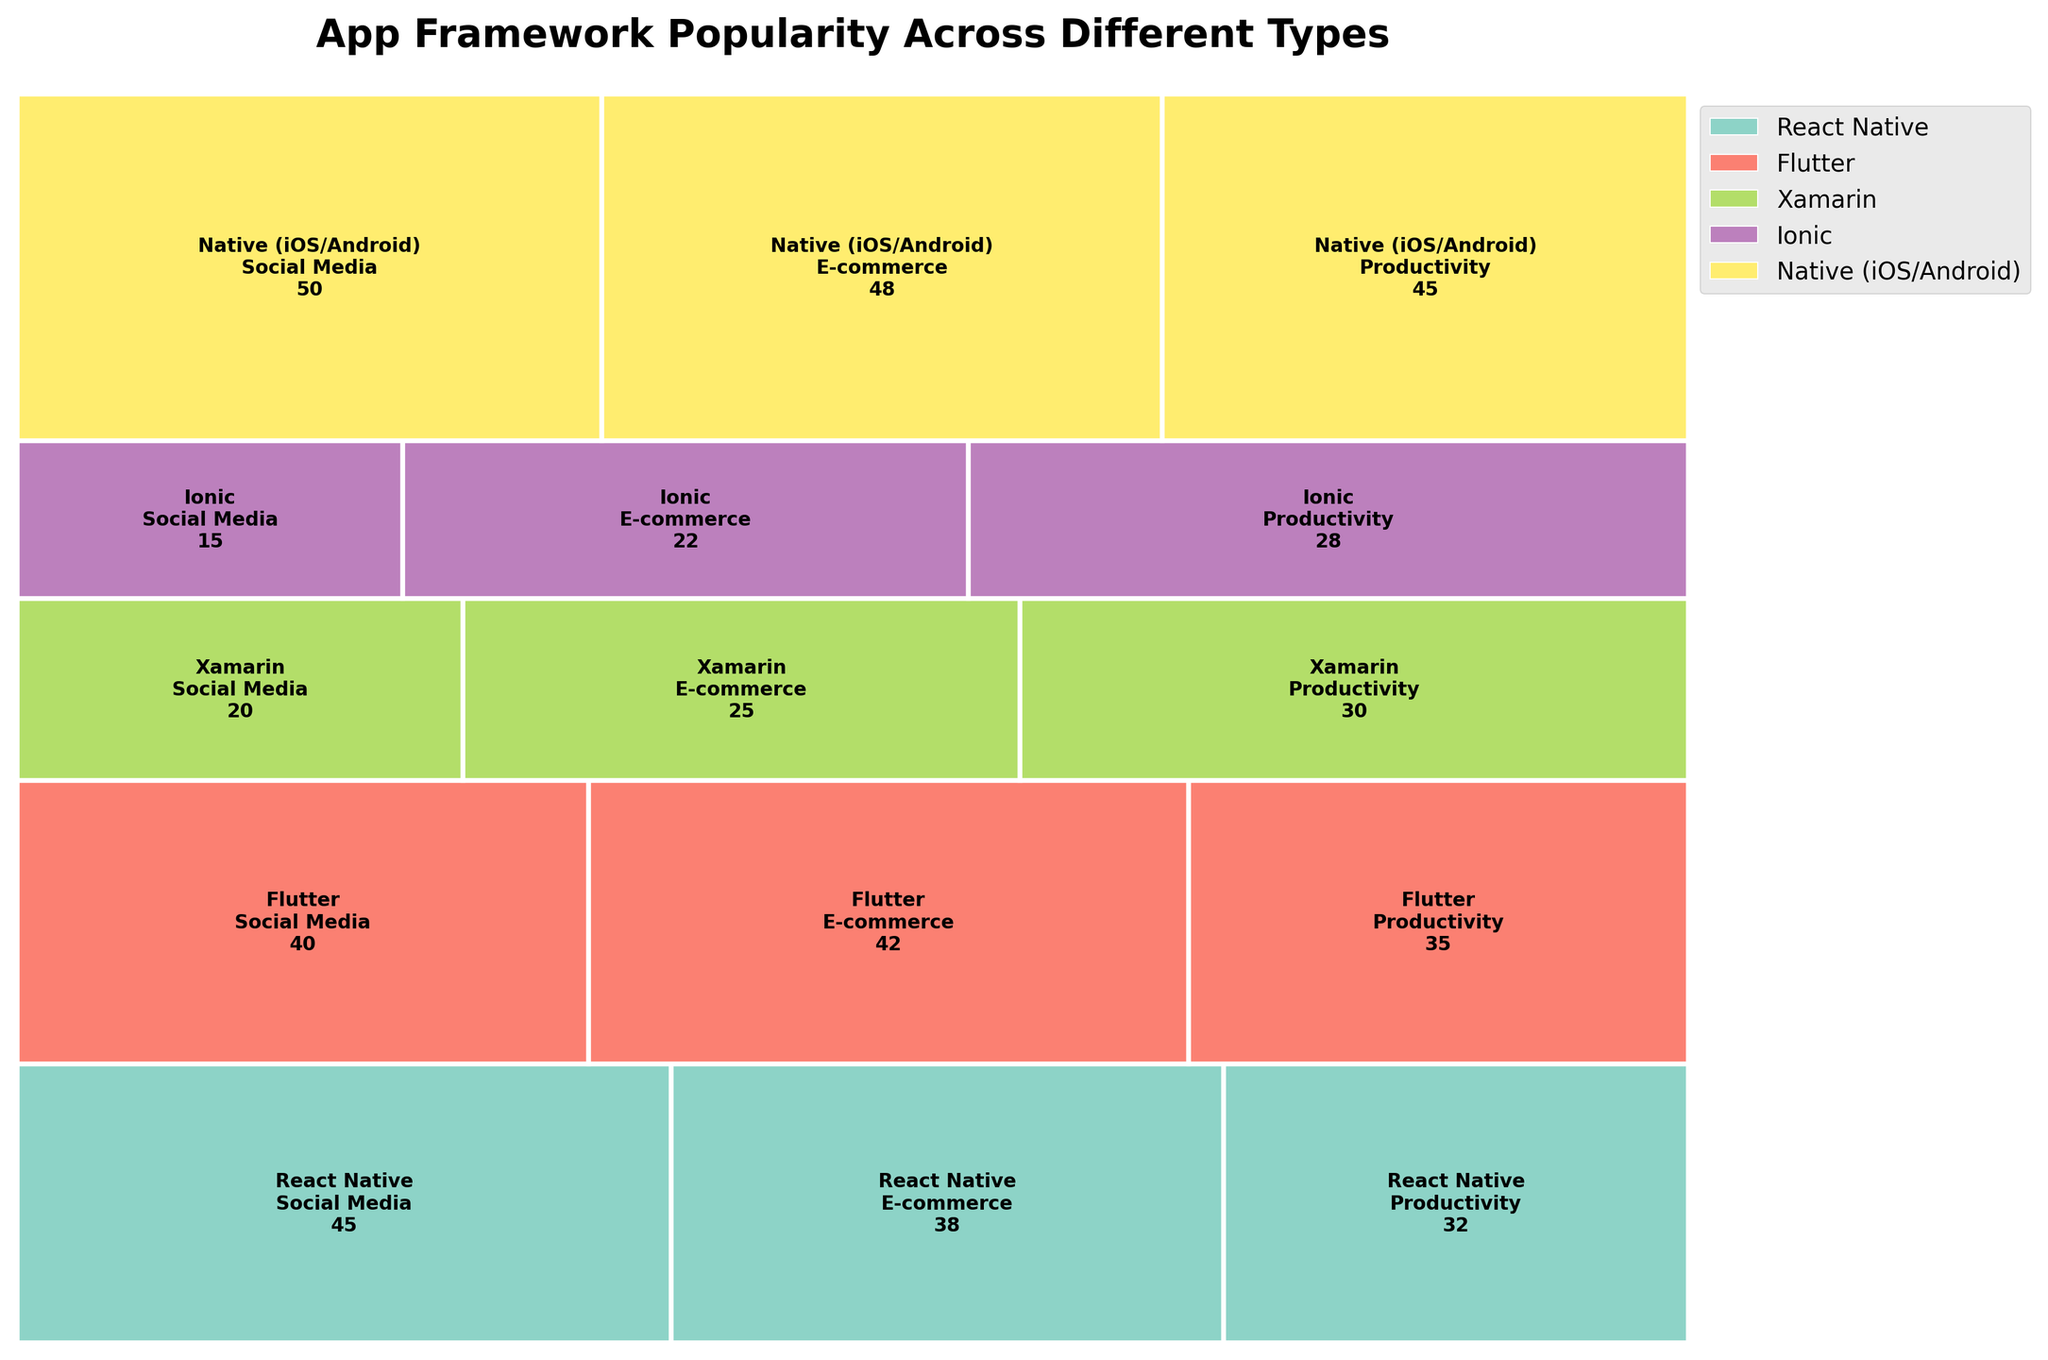What's the most popular framework for Social Media applications? The section for Native (iOS/Android) in the Social Media category is the largest in the plot. By observing the counts, Native (iOS/Android) has the highest count for Social Media applications, which is 50.
Answer: Native (iOS/Android) How does the popularity of React Native for E-commerce compare to Flutter for E-commerce? The count for React Native in the E-commerce category is 38, while the count for Flutter in the same category is 42. Flutter has a slightly higher count than React Native in E-commerce.
Answer: Flutter is more popular What is the total number of applications developed using Xamarin across all app types? Summing the counts for Xamarin across Social Media (20), E-commerce (25), and Productivity (30) gives a total of 75.
Answer: 75 Which app type has the least usage of the Ionic framework? Observing the plot, the section for Social Media under Ionic has the smallest value, which is 15.
Answer: Social Media What percentage of Social Media applications are developed using Flutter? The count for Flutter in Social Media is 40. The total count for Social Media applications across all frameworks is 45 + 40 + 20 + 15 + 50 = 170. The percentage is (40 / 170) * 100.
Answer: ~23.53% Which framework is most popular overall across all app types? By adding up the counts for each framework across all app types, Native (iOS/Android) has the highest total (50+48+45 = 143), while others have lower totals.
Answer: Native (iOS/Android) What is the difference in the number of E-commerce applications between Ionic and Xamarin? The count of E-commerce applications for Ionic is 22, and for Xamarin, it is 25. The difference is 25 - 22.
Answer: 3 Comparing React Native and Flutter, which has a higher total count of applications across all app types? Summing the counts for React Native (45 + 38 + 32 = 115) and Flutter (40 + 42 + 35 = 117), Flutter has a higher total count of applications.
Answer: Flutter In the Productivity category, which framework comes second in popularity? The counts for Productivity are: React Native (32), Flutter (35), Xamarin (30), Ionic (28), and Native (iOS/Android) (45). Flutter has the second-highest count after Native (iOS/Android).
Answer: Flutter How does the popularity of Native (iOS/Android) compare between E-commerce and Social Media applications? The count for Native (iOS/Android) in E-commerce is 48 and in Social Media is 50. The counts are very close, with only a difference of 2.
Answer: Almost equal (48 vs. 50) 